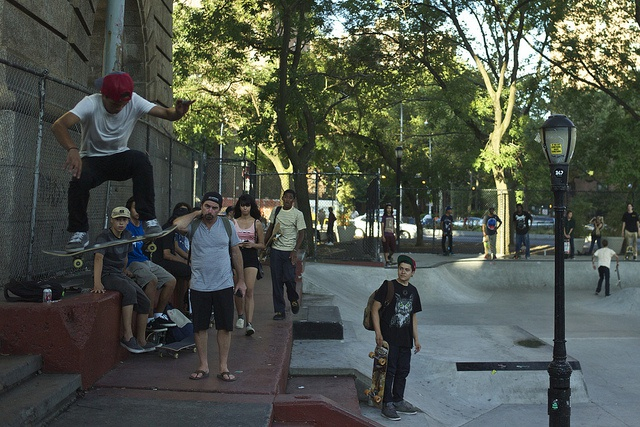Describe the objects in this image and their specific colors. I can see people in gray, black, purple, and maroon tones, people in gray and black tones, people in gray, black, and darkgray tones, people in gray, black, and purple tones, and people in gray and black tones in this image. 